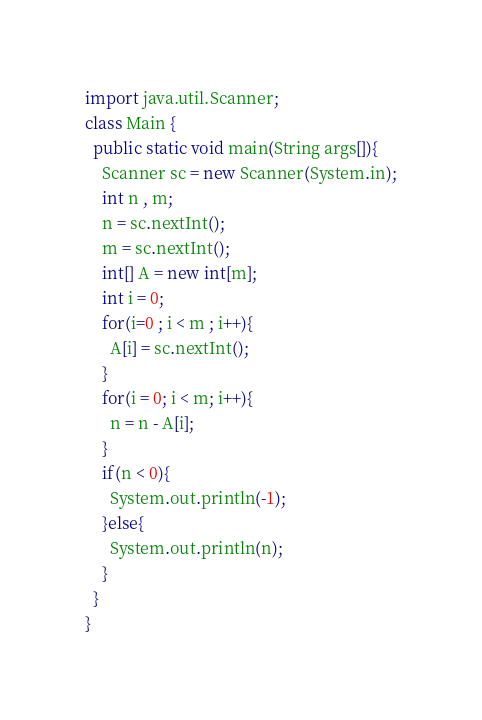<code> <loc_0><loc_0><loc_500><loc_500><_Java_>import java.util.Scanner;
class Main {
  public static void main(String args[]){
    Scanner sc = new Scanner(System.in);
    int n , m;
    n = sc.nextInt();
    m = sc.nextInt();
    int[] A = new int[m];
    int i = 0;
    for(i=0 ; i < m ; i++){
      A[i] = sc.nextInt();
    }
    for(i = 0; i < m; i++){
      n = n - A[i];
    }
    if(n < 0){
      System.out.println(-1);
    }else{
      System.out.println(n);
    }
  }
}
</code> 